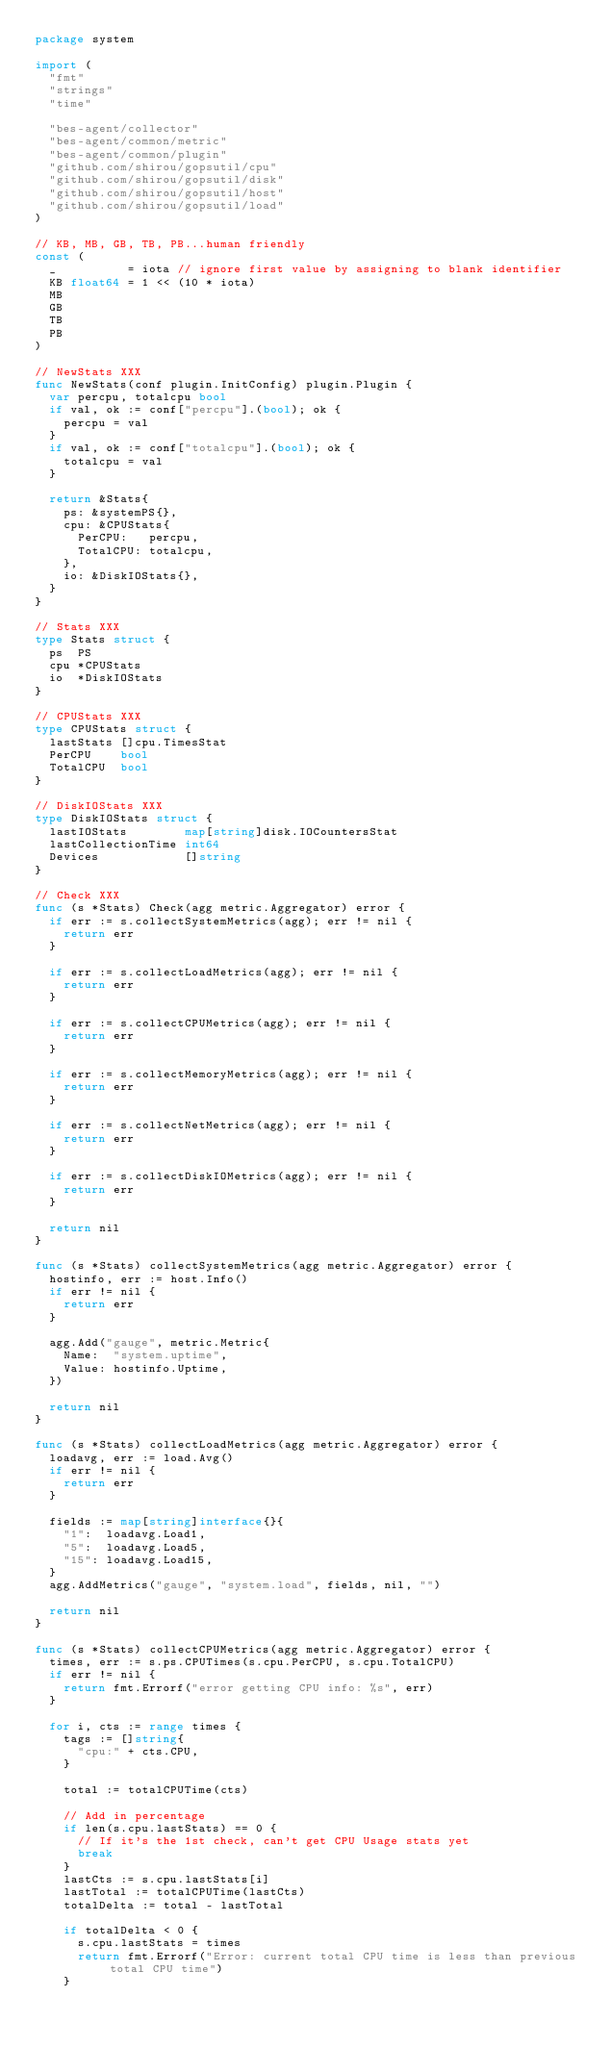<code> <loc_0><loc_0><loc_500><loc_500><_Go_>package system

import (
	"fmt"
	"strings"
	"time"

	"bes-agent/collector"
	"bes-agent/common/metric"
	"bes-agent/common/plugin"
	"github.com/shirou/gopsutil/cpu"
	"github.com/shirou/gopsutil/disk"
	"github.com/shirou/gopsutil/host"
	"github.com/shirou/gopsutil/load"
)

// KB, MB, GB, TB, PB...human friendly
const (
	_          = iota // ignore first value by assigning to blank identifier
	KB float64 = 1 << (10 * iota)
	MB
	GB
	TB
	PB
)

// NewStats XXX
func NewStats(conf plugin.InitConfig) plugin.Plugin {
	var percpu, totalcpu bool
	if val, ok := conf["percpu"].(bool); ok {
		percpu = val
	}
	if val, ok := conf["totalcpu"].(bool); ok {
		totalcpu = val
	}

	return &Stats{
		ps: &systemPS{},
		cpu: &CPUStats{
			PerCPU:   percpu,
			TotalCPU: totalcpu,
		},
		io: &DiskIOStats{},
	}
}

// Stats XXX
type Stats struct {
	ps  PS
	cpu *CPUStats
	io  *DiskIOStats
}

// CPUStats XXX
type CPUStats struct {
	lastStats []cpu.TimesStat
	PerCPU    bool
	TotalCPU  bool
}

// DiskIOStats XXX
type DiskIOStats struct {
	lastIOStats        map[string]disk.IOCountersStat
	lastCollectionTime int64
	Devices            []string
}

// Check XXX
func (s *Stats) Check(agg metric.Aggregator) error {
	if err := s.collectSystemMetrics(agg); err != nil {
		return err
	}

	if err := s.collectLoadMetrics(agg); err != nil {
		return err
	}

	if err := s.collectCPUMetrics(agg); err != nil {
		return err
	}

	if err := s.collectMemoryMetrics(agg); err != nil {
		return err
	}

	if err := s.collectNetMetrics(agg); err != nil {
		return err
	}

	if err := s.collectDiskIOMetrics(agg); err != nil {
		return err
	}

	return nil
}

func (s *Stats) collectSystemMetrics(agg metric.Aggregator) error {
	hostinfo, err := host.Info()
	if err != nil {
		return err
	}

	agg.Add("gauge", metric.Metric{
		Name:  "system.uptime",
		Value: hostinfo.Uptime,
	})

	return nil
}

func (s *Stats) collectLoadMetrics(agg metric.Aggregator) error {
	loadavg, err := load.Avg()
	if err != nil {
		return err
	}

	fields := map[string]interface{}{
		"1":  loadavg.Load1,
		"5":  loadavg.Load5,
		"15": loadavg.Load15,
	}
	agg.AddMetrics("gauge", "system.load", fields, nil, "")

	return nil
}

func (s *Stats) collectCPUMetrics(agg metric.Aggregator) error {
	times, err := s.ps.CPUTimes(s.cpu.PerCPU, s.cpu.TotalCPU)
	if err != nil {
		return fmt.Errorf("error getting CPU info: %s", err)
	}

	for i, cts := range times {
		tags := []string{
			"cpu:" + cts.CPU,
		}

		total := totalCPUTime(cts)

		// Add in percentage
		if len(s.cpu.lastStats) == 0 {
			// If it's the 1st check, can't get CPU Usage stats yet
			break
		}
		lastCts := s.cpu.lastStats[i]
		lastTotal := totalCPUTime(lastCts)
		totalDelta := total - lastTotal

		if totalDelta < 0 {
			s.cpu.lastStats = times
			return fmt.Errorf("Error: current total CPU time is less than previous total CPU time")
		}
</code> 